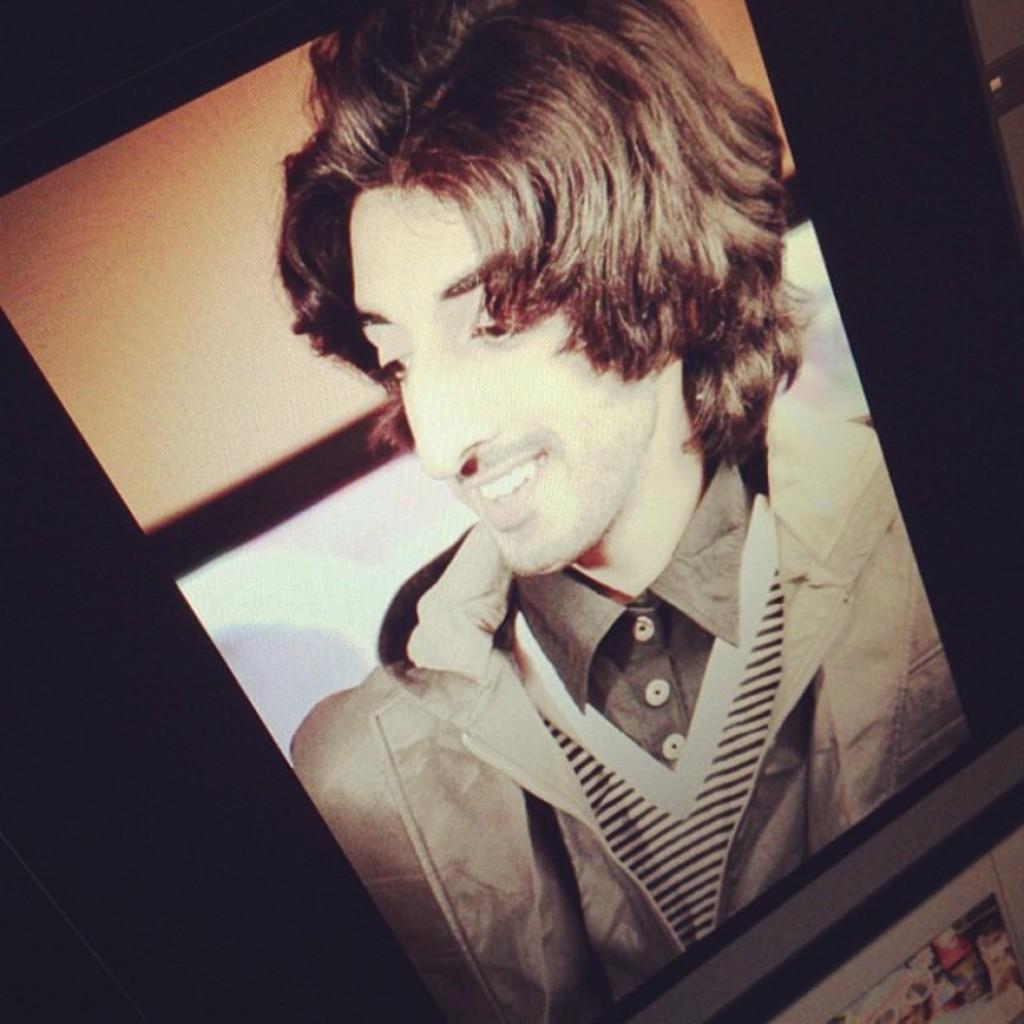Can you describe this image briefly? In this image I can see a picture of a man and also he is smiling. 